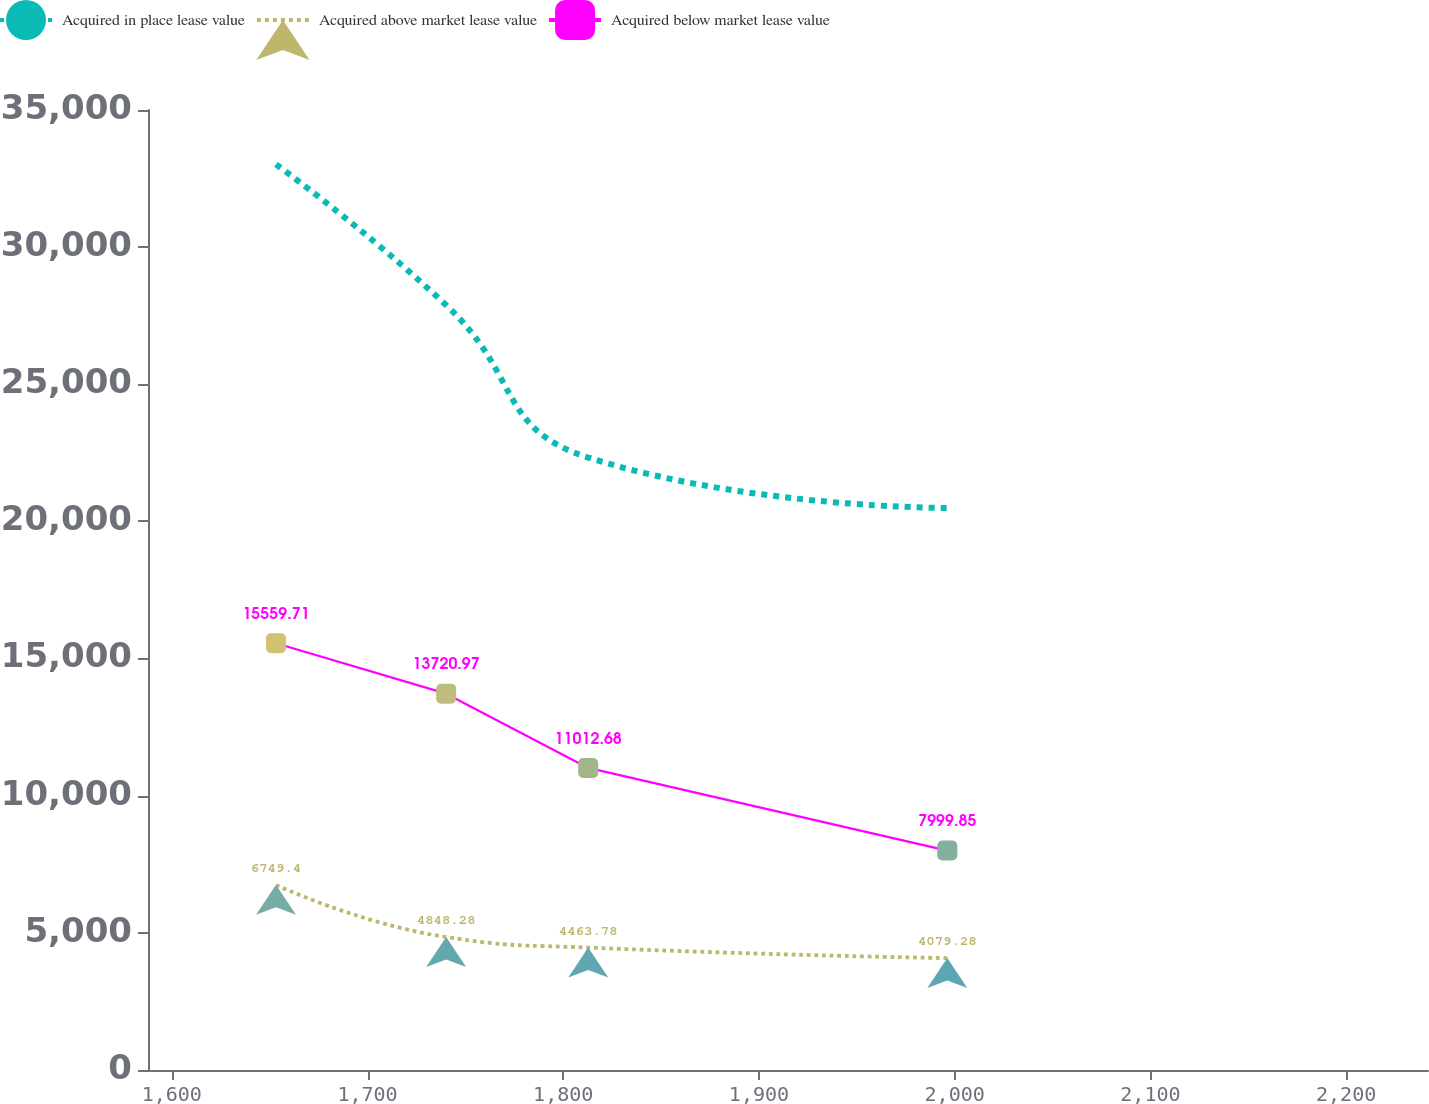<chart> <loc_0><loc_0><loc_500><loc_500><line_chart><ecel><fcel>Acquired in place lease value<fcel>Acquired above market lease value<fcel>Acquired below market lease value<nl><fcel>1653.25<fcel>33020<fcel>6749.4<fcel>15559.7<nl><fcel>1740.19<fcel>27885<fcel>4848.28<fcel>13721<nl><fcel>1812.76<fcel>22328.5<fcel>4463.78<fcel>11012.7<nl><fcel>1996.23<fcel>20490.7<fcel>4079.28<fcel>7999.85<nl><fcel>2307.23<fcel>14641.6<fcel>2904.44<fcel>6607.48<nl></chart> 